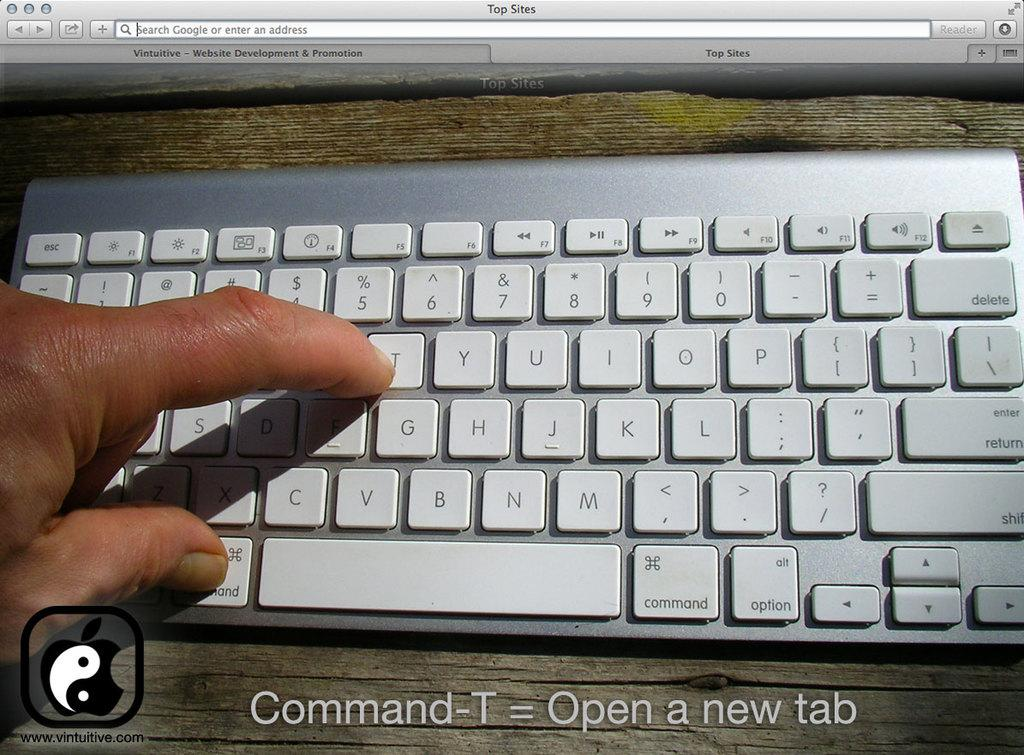<image>
Offer a succinct explanation of the picture presented. A keyboard is shown with instructions on how to open a new tab. 